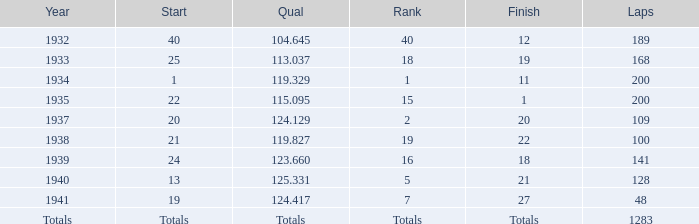What was the rank with the qual of 115.095? 15.0. 